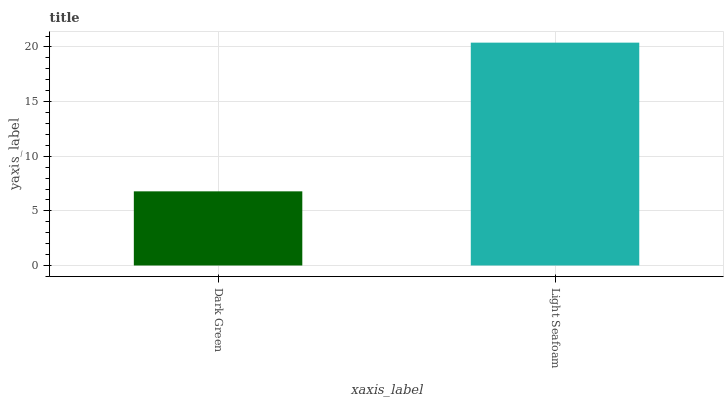Is Dark Green the minimum?
Answer yes or no. Yes. Is Light Seafoam the maximum?
Answer yes or no. Yes. Is Light Seafoam the minimum?
Answer yes or no. No. Is Light Seafoam greater than Dark Green?
Answer yes or no. Yes. Is Dark Green less than Light Seafoam?
Answer yes or no. Yes. Is Dark Green greater than Light Seafoam?
Answer yes or no. No. Is Light Seafoam less than Dark Green?
Answer yes or no. No. Is Light Seafoam the high median?
Answer yes or no. Yes. Is Dark Green the low median?
Answer yes or no. Yes. Is Dark Green the high median?
Answer yes or no. No. Is Light Seafoam the low median?
Answer yes or no. No. 